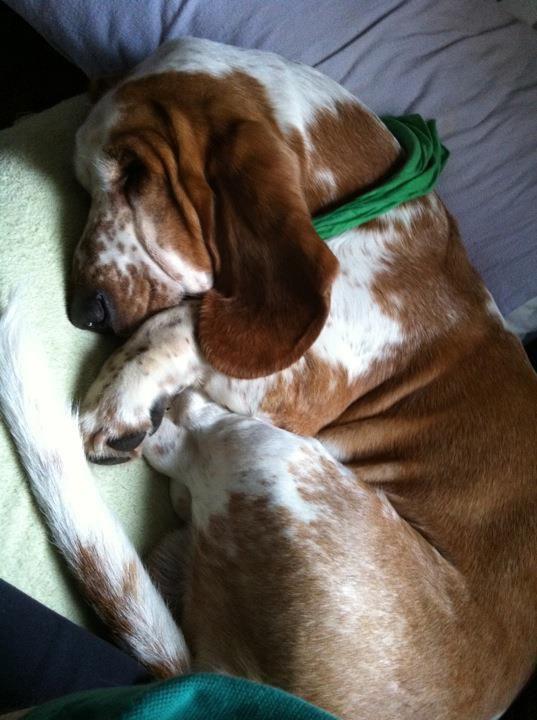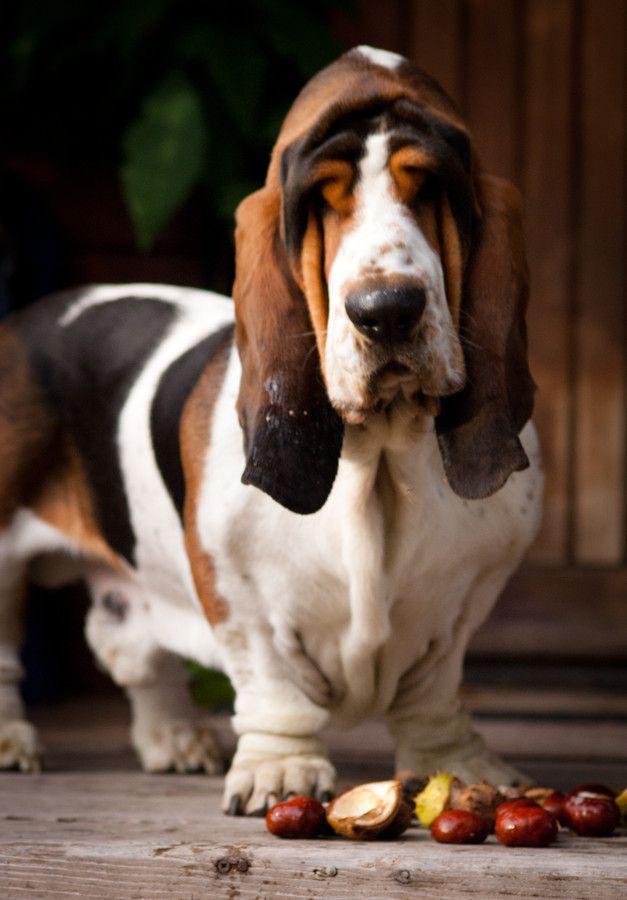The first image is the image on the left, the second image is the image on the right. Given the left and right images, does the statement "At least one image contains a human being." hold true? Answer yes or no. No. The first image is the image on the left, the second image is the image on the right. Given the left and right images, does the statement "There is a droopy dog being held by a person in one image, and a droopy dog with no person in the other." hold true? Answer yes or no. No. 